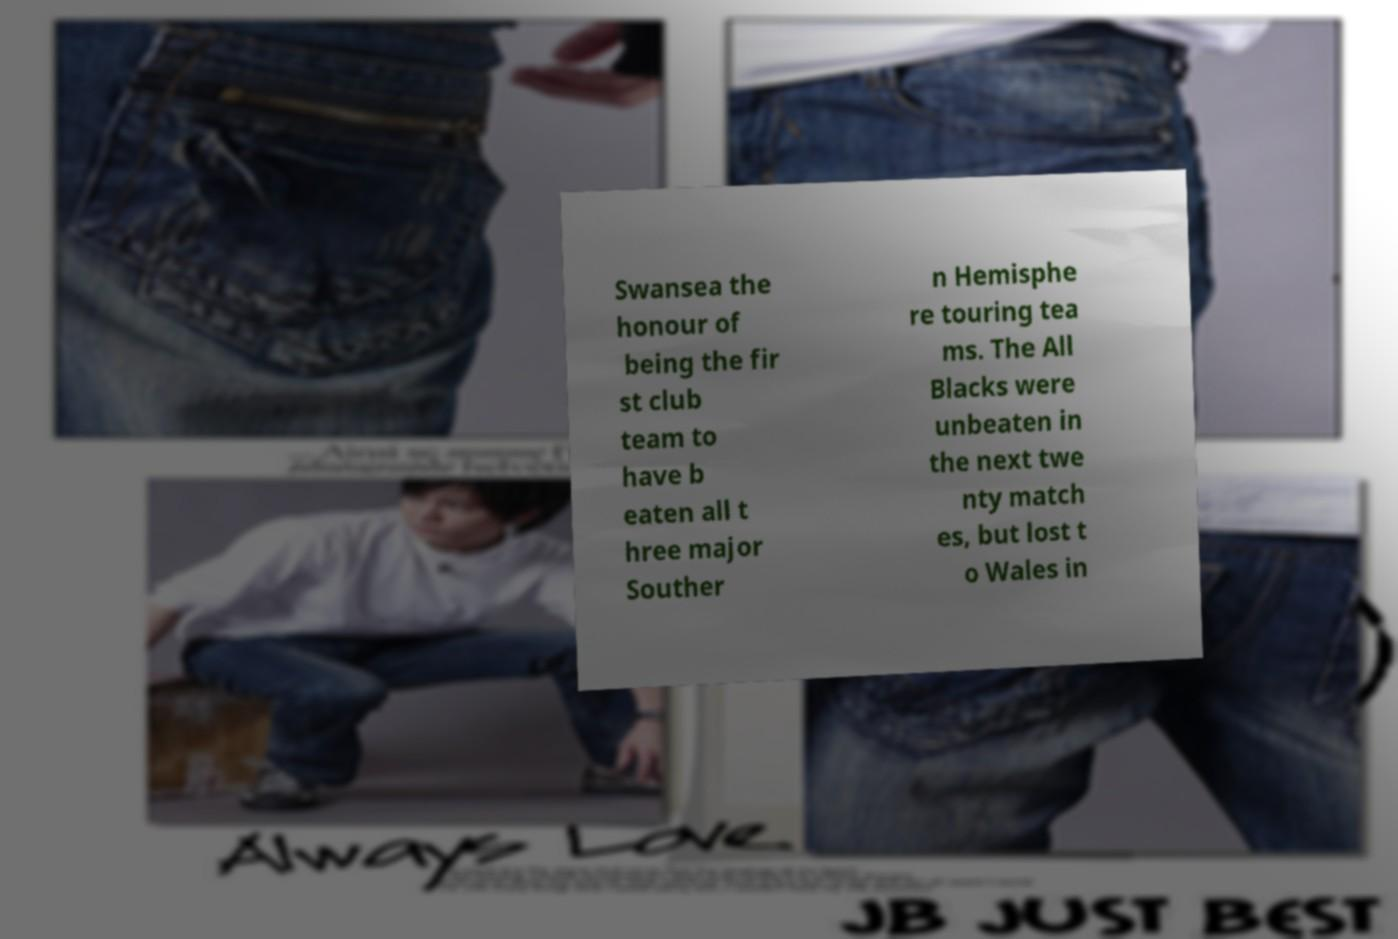There's text embedded in this image that I need extracted. Can you transcribe it verbatim? Swansea the honour of being the fir st club team to have b eaten all t hree major Souther n Hemisphe re touring tea ms. The All Blacks were unbeaten in the next twe nty match es, but lost t o Wales in 